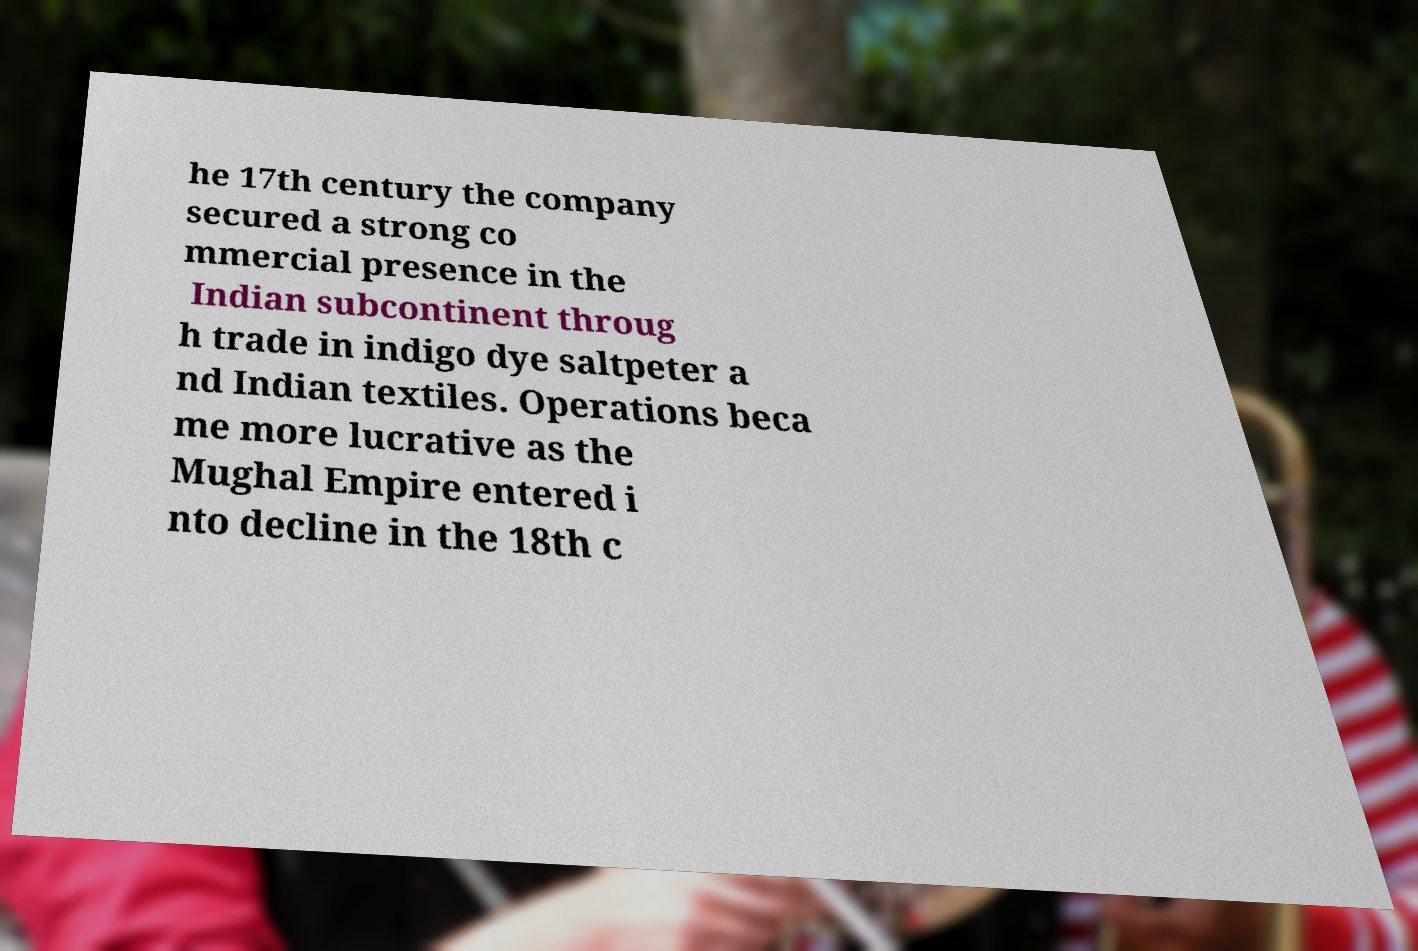Can you read and provide the text displayed in the image?This photo seems to have some interesting text. Can you extract and type it out for me? he 17th century the company secured a strong co mmercial presence in the Indian subcontinent throug h trade in indigo dye saltpeter a nd Indian textiles. Operations beca me more lucrative as the Mughal Empire entered i nto decline in the 18th c 